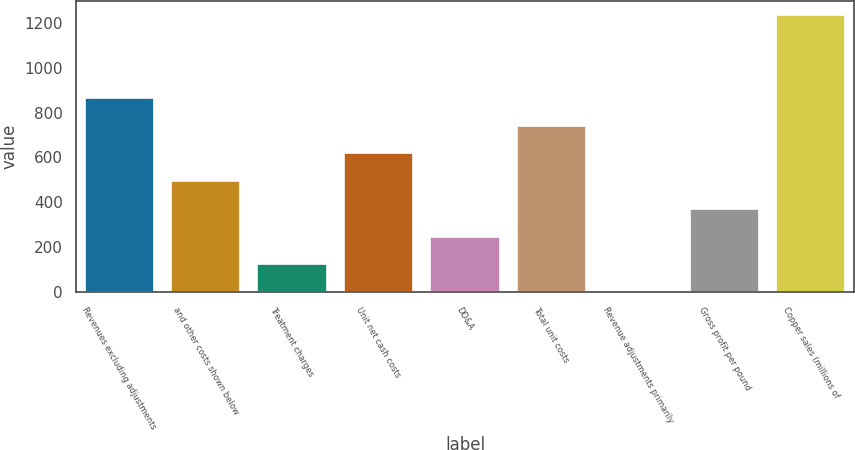<chart> <loc_0><loc_0><loc_500><loc_500><bar_chart><fcel>Revenues excluding adjustments<fcel>and other costs shown below<fcel>Treatment charges<fcel>Unit net cash costs<fcel>DD&A<fcel>Total unit costs<fcel>Revenue adjustments primarily<fcel>Gross profit per pound<fcel>Copper sales (millions of<nl><fcel>864.53<fcel>494.03<fcel>123.53<fcel>617.53<fcel>247.03<fcel>741.03<fcel>0.03<fcel>370.53<fcel>1235<nl></chart> 